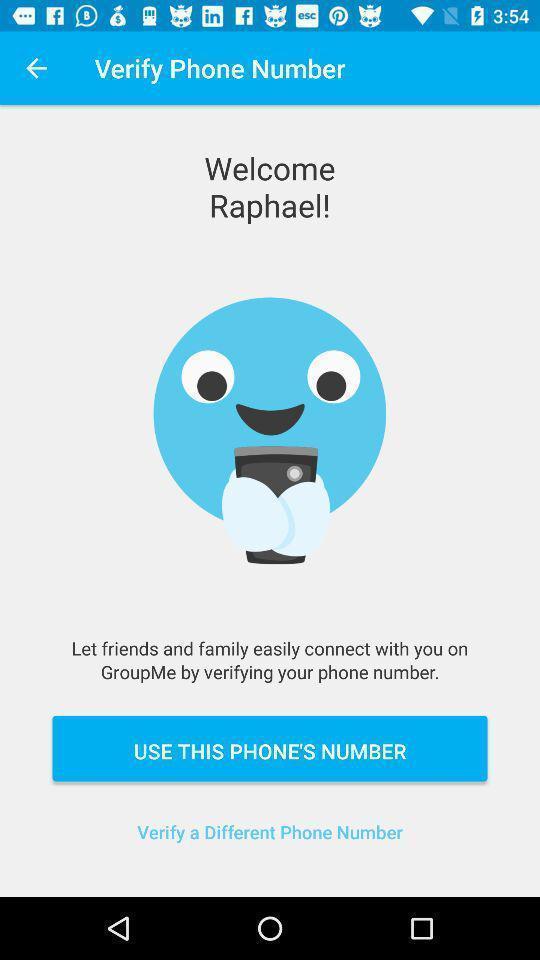Give me a summary of this screen capture. Welcome page. 